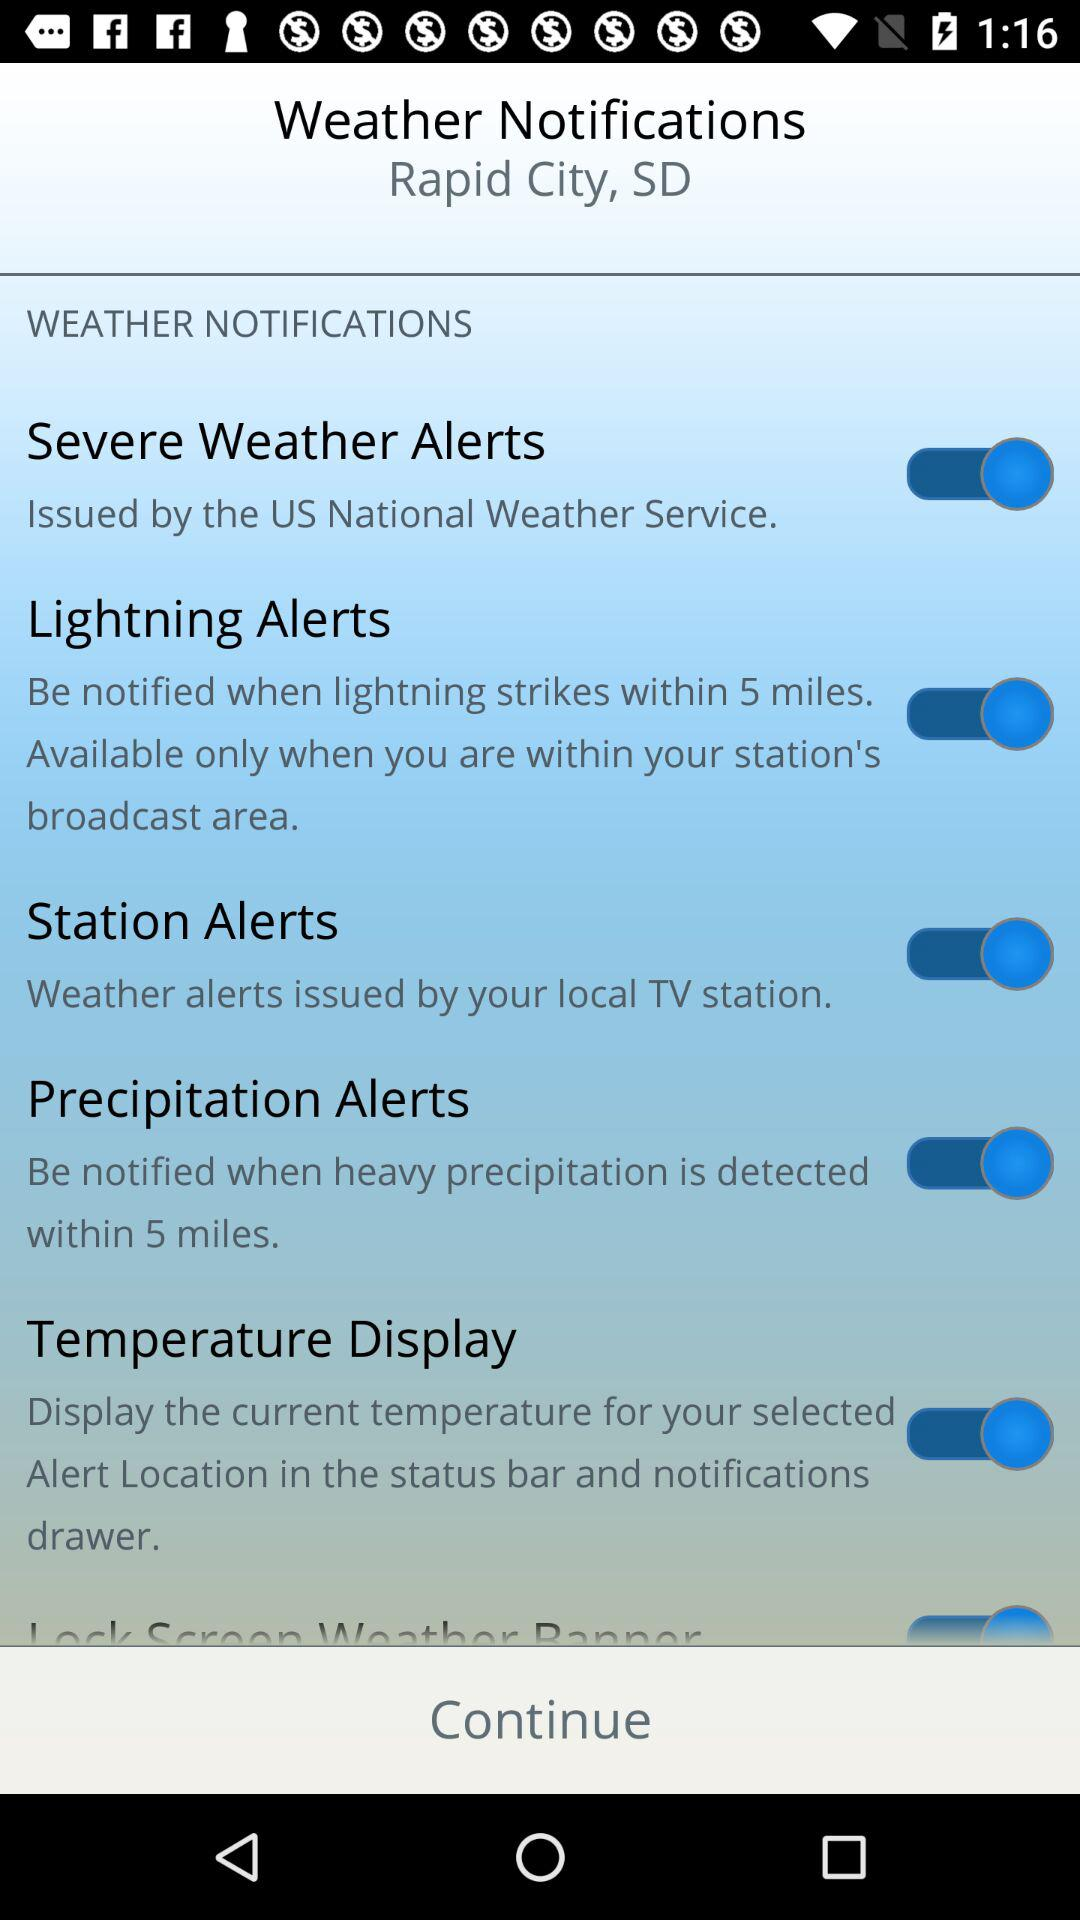What is the name of your local TV station?
When the provided information is insufficient, respond with <no answer>. <no answer> 